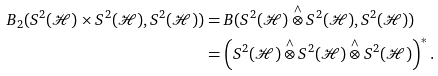<formula> <loc_0><loc_0><loc_500><loc_500>B _ { 2 } ( S ^ { 2 } ( \mathcal { H } ) \times S ^ { 2 } ( \mathcal { H } ) , S ^ { 2 } ( \mathcal { H } ) ) & = B ( S ^ { 2 } ( \mathcal { H } ) \overset { \wedge } { \otimes } S ^ { 2 } ( \mathcal { H } ) , S ^ { 2 } ( \mathcal { H } ) ) \\ & = \left ( S ^ { 2 } ( \mathcal { H } ) \overset { \wedge } { \otimes } S ^ { 2 } ( \mathcal { H } ) \overset { \wedge } { \otimes } S ^ { 2 } ( \mathcal { H } ) \right ) ^ { * } .</formula> 